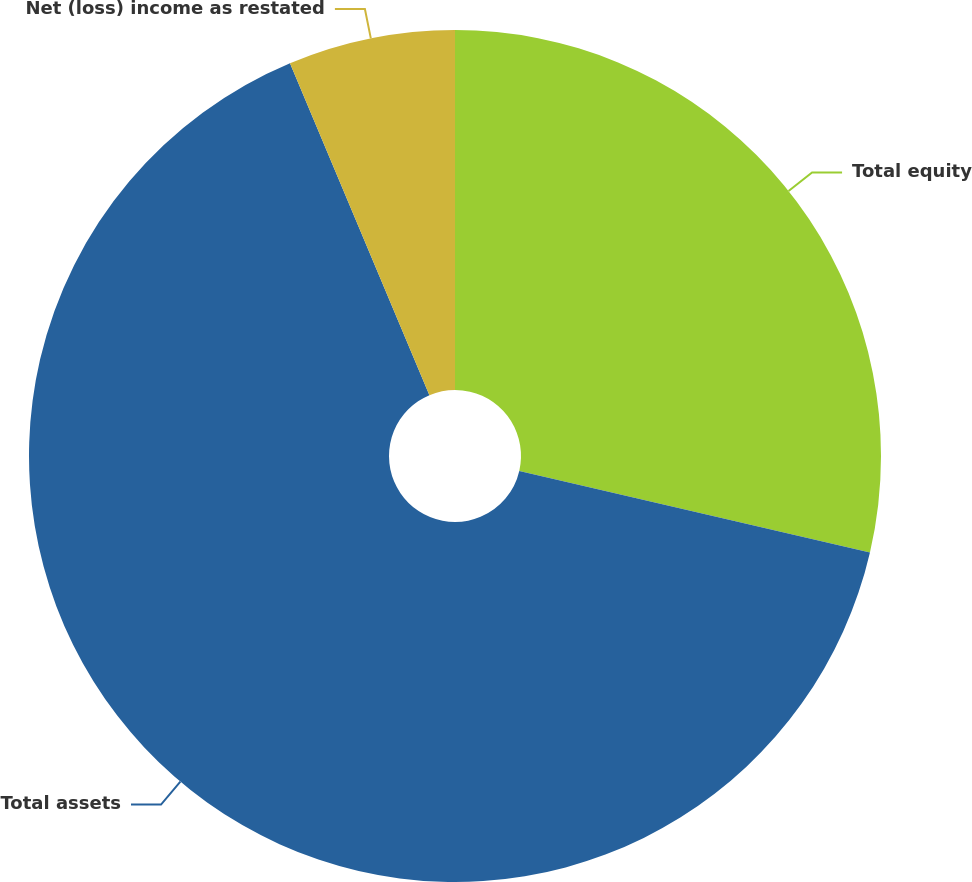Convert chart. <chart><loc_0><loc_0><loc_500><loc_500><pie_chart><fcel>Total equity<fcel>Total assets<fcel>Net (loss) income as restated<nl><fcel>28.63%<fcel>65.03%<fcel>6.33%<nl></chart> 